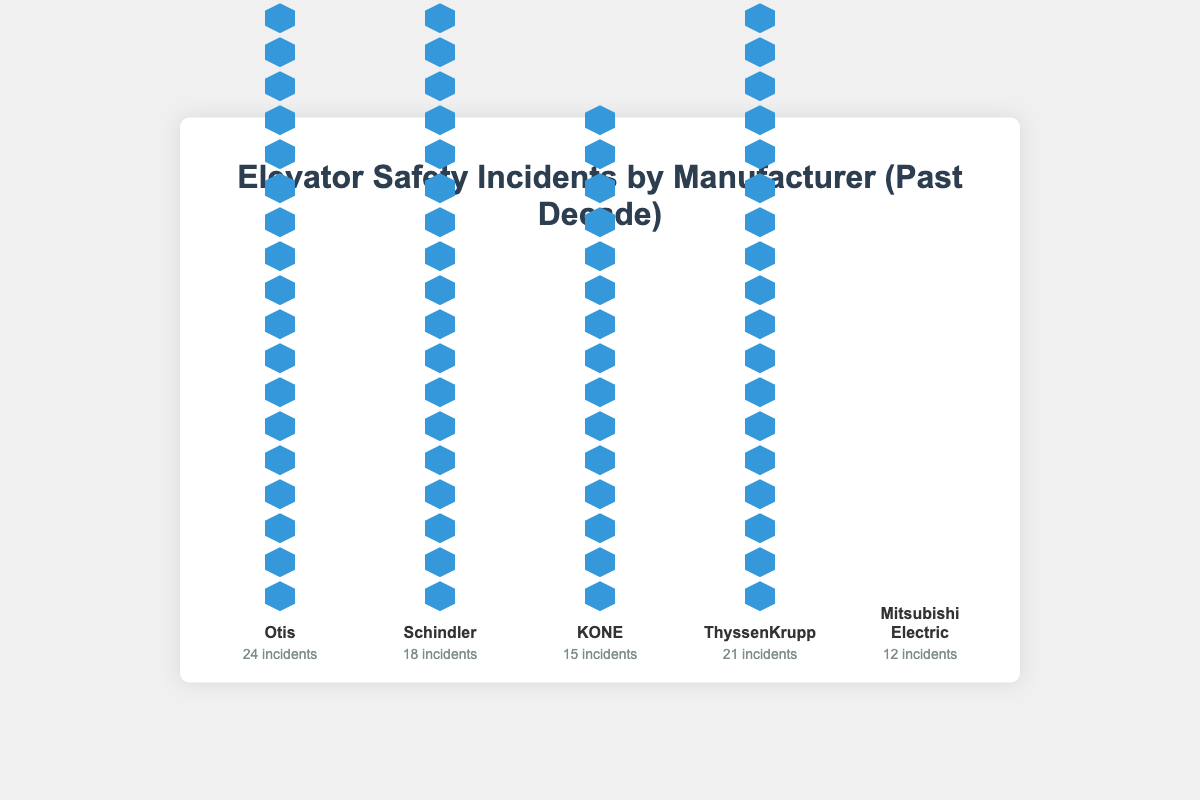Which manufacturer has the highest number of safety incidents? By observing the plot, Otis has the most icons representing the number of incidents. This number is also explicitly stated beside the name Otis.
Answer: Otis Which manufacturer has the lowest number of incidents? Mitsubishi Electric has the least number of icons. The figure states that Mitsubishi Electric has 12 incidents.
Answer: Mitsubishi Electric How many incidents do Schindler and KONE have combined? Schindler has 18 incidents and KONE has 15 incidents. Adding them together: 18 + 15 = 33.
Answer: 33 What is the difference in the number of safety incidents between Otis and ThyssenKrupp? Otis has 24 incidents, and ThyssenKrupp has 21 incidents. The difference between them is 24 - 21 = 3.
Answer: 3 Rank the manufacturers from most incidents to least incidents. Otis (24) > ThyssenKrupp (21) > Schindler (18) > KONE (15) > Mitsubishi Electric (12), based on the number of icons.
Answer: Otis, ThyssenKrupp, Schindler, KONE, Mitsubishi Electric How many incidents do all manufacturers have in total? Sum up the incidents for all manufacturers: 24 (Otis) + 18 (Schindler) + 15 (KONE) + 21 (ThyssenKrupp) + 12 (Mitsubishi Electric) = 90.
Answer: 90 By how much does KONE have fewer incidents than Schindler? Schindler has 18 incidents, and KONE has 15. The difference is 18 - 15 = 3.
Answer: 3 What percentage of the total incidents is attributed to ThyssenKrupp? ThyssenKrupp has 21 incidents out of a total of 90 incidents. The percentage is (21 / 90) * 100 ≈ 23.33%.
Answer: 23.33% Which two manufacturers have a combined total of 39 incidents? By checking combinations: Otis (24) + KONE (15) = 39. Thus, Otis and KONE combined have 39 incidents.
Answer: Otis and KONE Do any manufacturers have the same number of safety incidents? No, all manufacturers have a different number of incidents: Otis (24), Schindler (18), KONE (15), ThyssenKrupp (21), Mitsubishi Electric (12).
Answer: No 